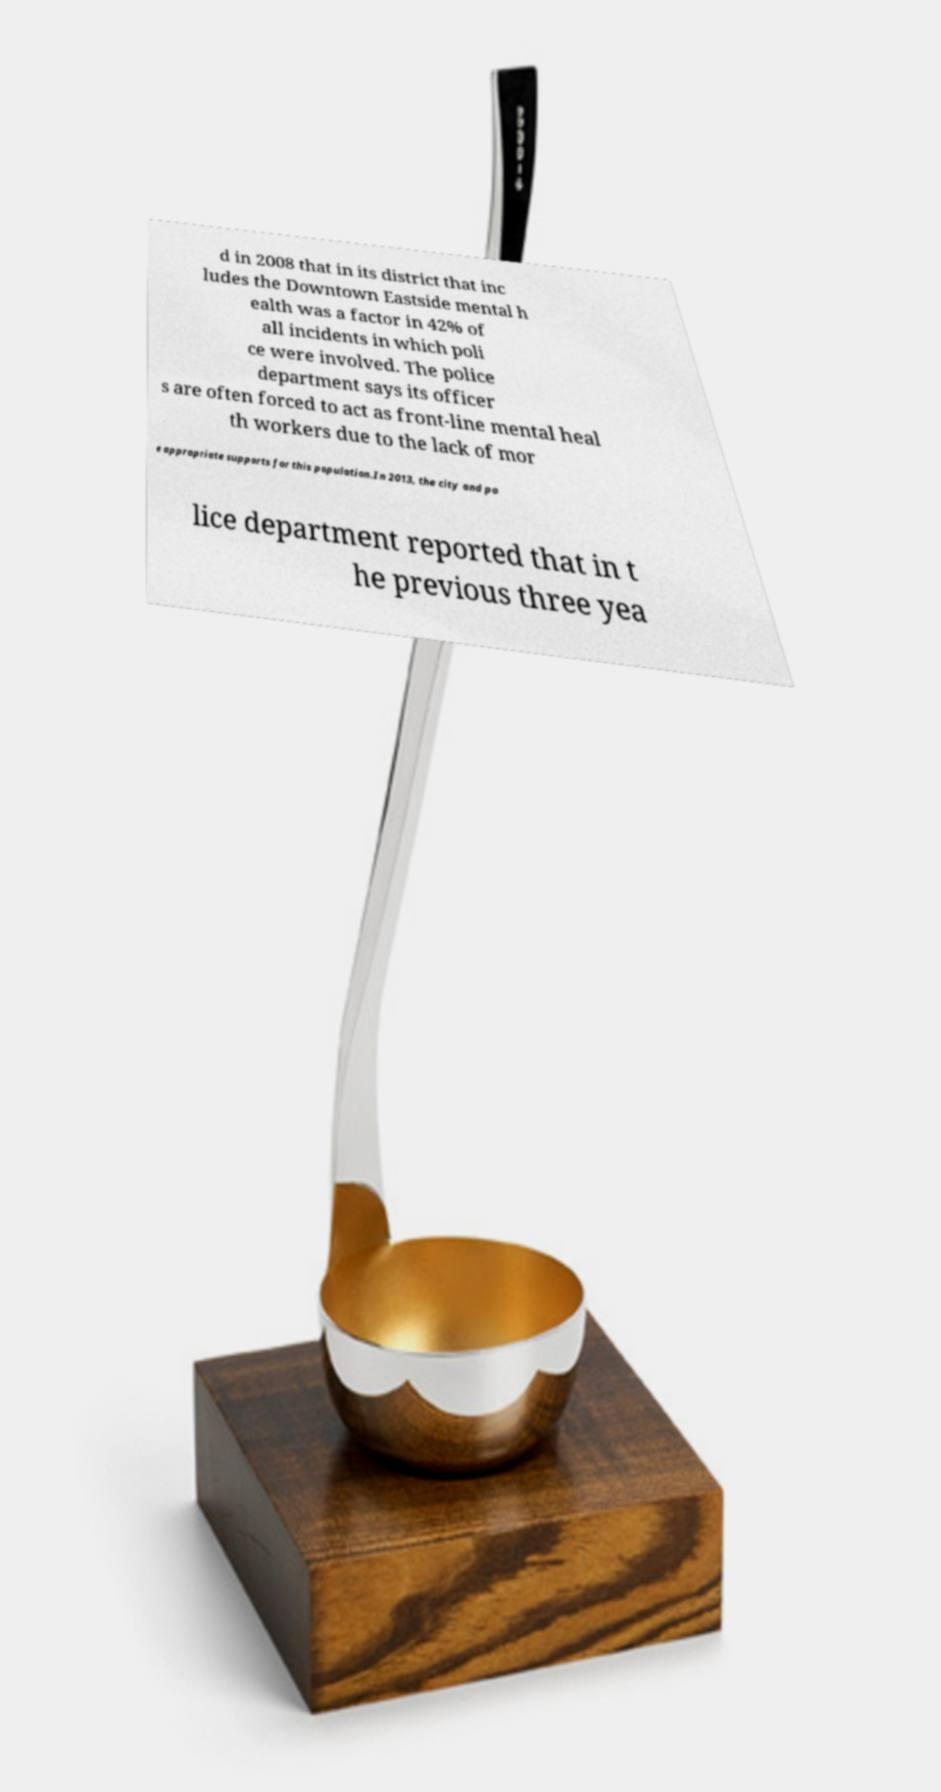What messages or text are displayed in this image? I need them in a readable, typed format. d in 2008 that in its district that inc ludes the Downtown Eastside mental h ealth was a factor in 42% of all incidents in which poli ce were involved. The police department says its officer s are often forced to act as front-line mental heal th workers due to the lack of mor e appropriate supports for this population.In 2013, the city and po lice department reported that in t he previous three yea 